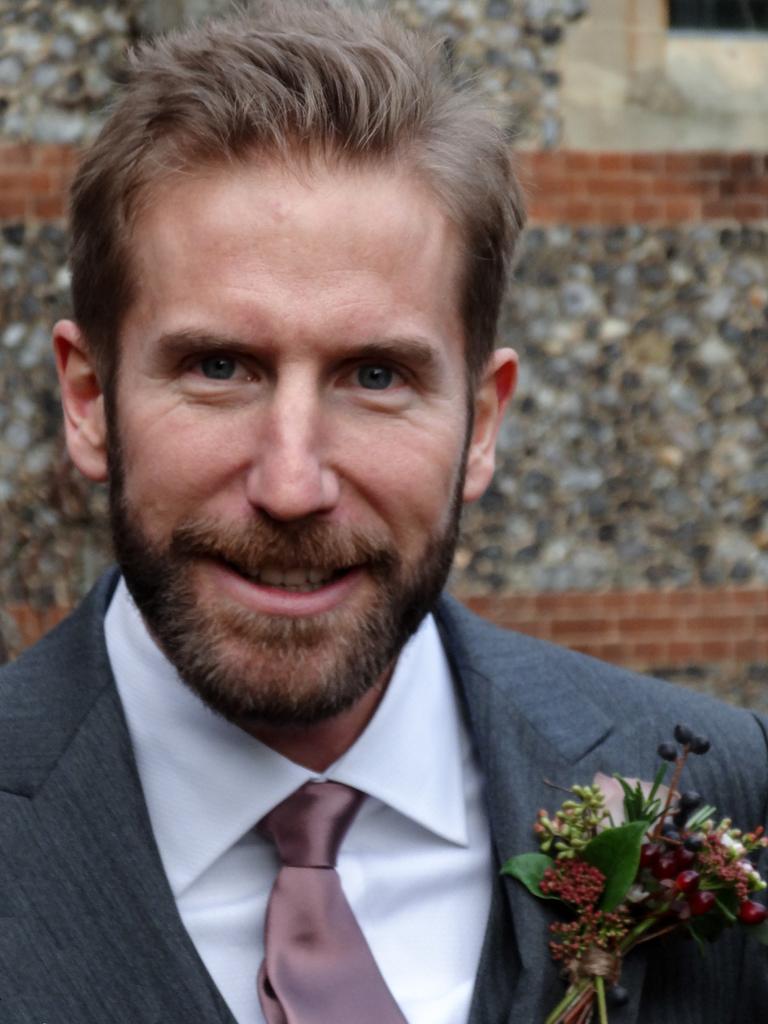Could you give a brief overview of what you see in this image? In this image we can see a person with a suit and he is smiling. In the background of the image there is the wall. 